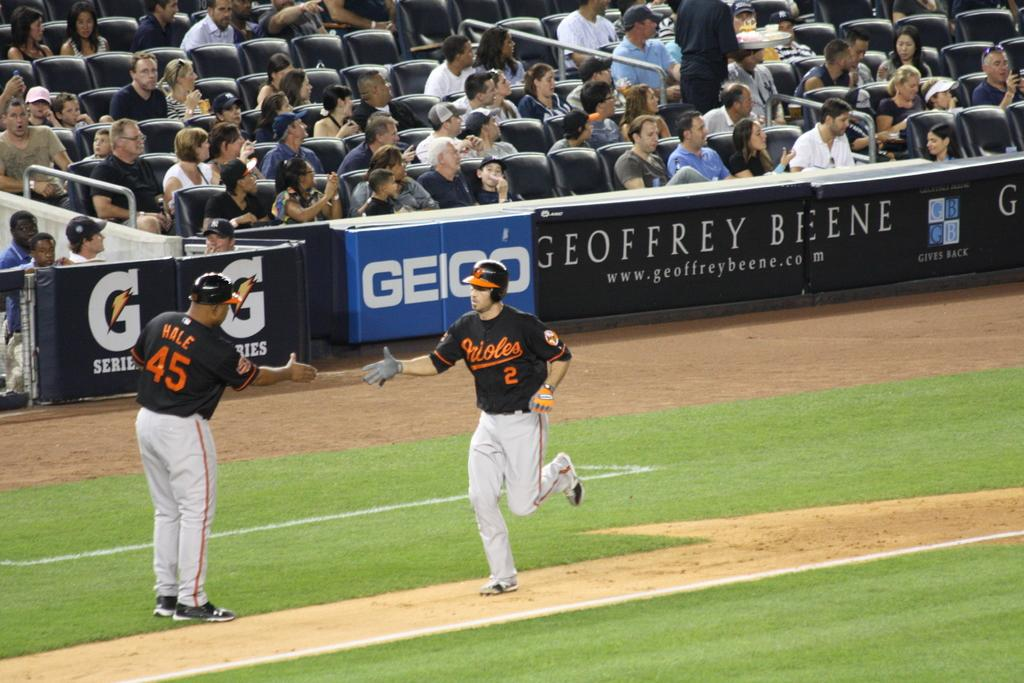<image>
Write a terse but informative summary of the picture. An Orioles player wearing number 2 heads to home plate while his teammate congratulates him. 